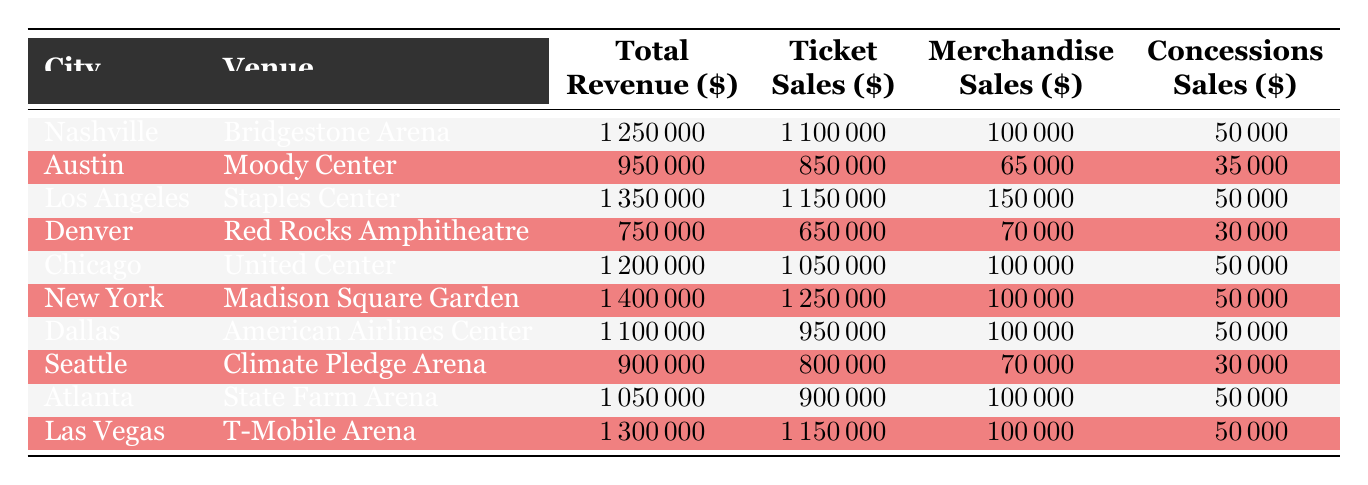What city generated the highest total revenue? By examining the total revenue column, the highest value can be found. In the provided data, New York has the highest total revenue of 1,400,000.
Answer: New York What are the total revenue and ticket sales for Las Vegas? Referring to the row for Las Vegas, the total revenue is 1,300,000, and ticket sales are 1,150,000.
Answer: Total revenue: 1,300,000; Ticket sales: 1,150,000 Which city had the lowest total revenue, and what was the amount? Checking the total revenue column, Denver shows the lowest amount at 750,000.
Answer: Denver; 750,000 What is the average ticket sales across all venues? To calculate the average ticket sales, sum all ticket sales: (1,100,000 + 850,000 + 1,150,000 + 650,000 + 1,050,000 + 1,250,000 + 950,000 + 800,000 + 900,000 + 1,150,000) = 10,600,000. Then, dividing by the total number of venues (10), the average is 10,600,000/10 = 1,060,000.
Answer: 1,060,000 Did merchandise sales in Chicago exceed those in Austin? Comparing the merchandise sales, Chicago has 100,000, while Austin has 65,000. Since 100,000 is greater than 65,000, the statement is true.
Answer: Yes 